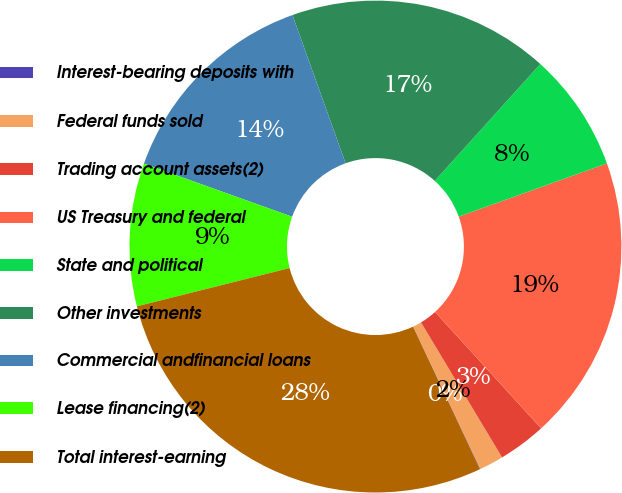<chart> <loc_0><loc_0><loc_500><loc_500><pie_chart><fcel>Interest-bearing deposits with<fcel>Federal funds sold<fcel>Trading account assets(2)<fcel>US Treasury and federal<fcel>State and political<fcel>Other investments<fcel>Commercial andfinancial loans<fcel>Lease financing(2)<fcel>Total interest-earning<nl><fcel>0.03%<fcel>1.59%<fcel>3.15%<fcel>18.73%<fcel>7.82%<fcel>17.17%<fcel>14.05%<fcel>9.38%<fcel>28.08%<nl></chart> 